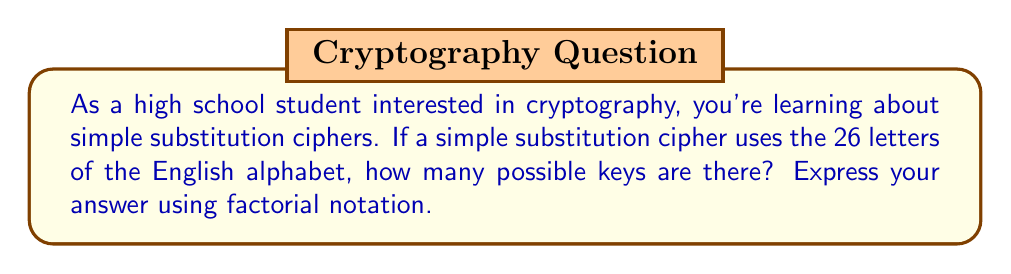Can you answer this question? Let's approach this step-by-step:

1) In a simple substitution cipher, each letter of the plaintext alphabet is mapped to a unique letter in the ciphertext alphabet.

2) We start with 26 choices for the first letter of the ciphertext alphabet.

3) After choosing the first letter, we have 25 choices for the second letter.

4) For the third letter, we have 24 choices, and so on.

5) This continues until we reach the last letter, for which we have only 1 choice left.

6) Mathematically, this can be represented as:

   $26 \times 25 \times 24 \times ... \times 2 \times 1$

7) In factorial notation, this is written as:

   $26!$

8) To understand the magnitude of this number:
   
   $26! = 403,291,461,126,605,635,584,000,000$

This incredibly large number demonstrates why simple substitution ciphers, despite being easy to implement, can be challenging to break by brute force methods alone.
Answer: $26!$ 